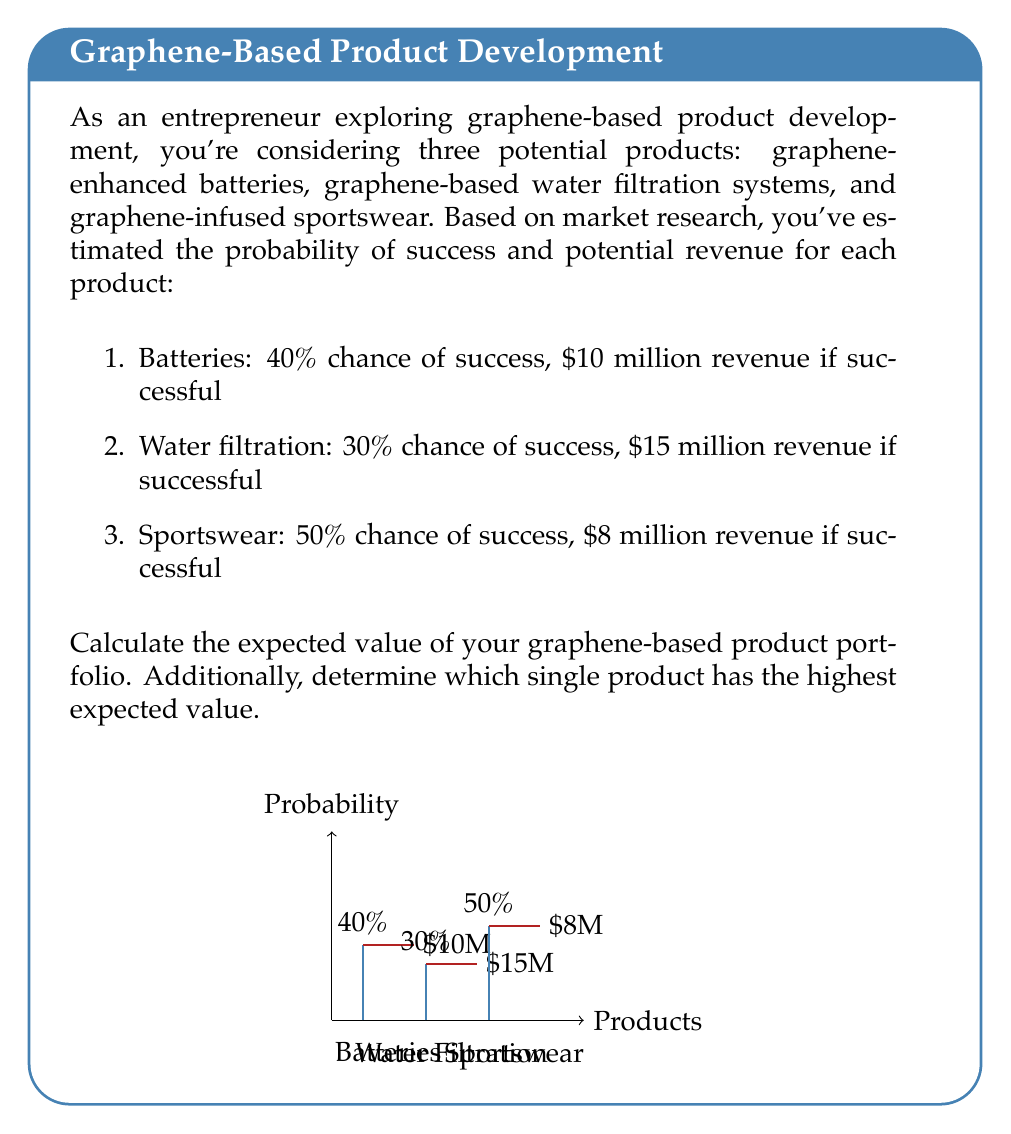Show me your answer to this math problem. To solve this problem, we'll use the concept of expected value, which is calculated by multiplying the probability of an event occurring by its potential outcome.

Step 1: Calculate the expected value for each product.

1. Batteries:
   $EV_{batteries} = 0.40 \times \$10,000,000 = \$4,000,000$

2. Water filtration:
   $EV_{filtration} = 0.30 \times \$15,000,000 = \$4,500,000$

3. Sportswear:
   $EV_{sportswear} = 0.50 \times \$8,000,000 = \$4,000,000$

Step 2: Calculate the total expected value of the portfolio by summing the individual expected values.

$EV_{total} = EV_{batteries} + EV_{filtration} + EV_{sportswear}$
$EV_{total} = \$4,000,000 + \$4,500,000 + \$4,000,000 = \$12,500,000$

Step 3: Determine which single product has the highest expected value.

Comparing the expected values:
- Batteries: $\$4,000,000$
- Water filtration: $\$4,500,000$
- Sportswear: $\$4,000,000$

The water filtration system has the highest expected value at $\$4,500,000$.
Answer: $\$12,500,000; Water filtration system 